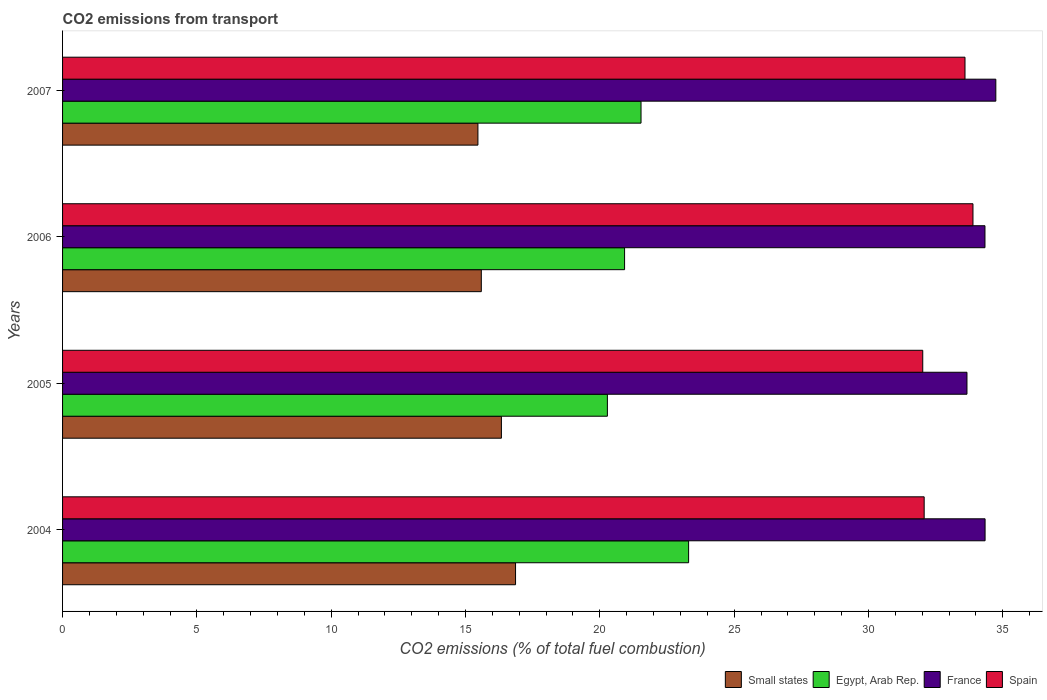How many different coloured bars are there?
Provide a short and direct response. 4. How many groups of bars are there?
Give a very brief answer. 4. How many bars are there on the 2nd tick from the top?
Keep it short and to the point. 4. What is the total CO2 emitted in Small states in 2006?
Your response must be concise. 15.59. Across all years, what is the maximum total CO2 emitted in Egypt, Arab Rep.?
Your answer should be compact. 23.3. Across all years, what is the minimum total CO2 emitted in France?
Make the answer very short. 33.67. In which year was the total CO2 emitted in Spain minimum?
Your answer should be compact. 2005. What is the total total CO2 emitted in Spain in the graph?
Provide a succinct answer. 131.57. What is the difference between the total CO2 emitted in Spain in 2006 and that in 2007?
Provide a succinct answer. 0.3. What is the difference between the total CO2 emitted in France in 2006 and the total CO2 emitted in Egypt, Arab Rep. in 2007?
Your answer should be compact. 12.8. What is the average total CO2 emitted in Egypt, Arab Rep. per year?
Keep it short and to the point. 21.51. In the year 2004, what is the difference between the total CO2 emitted in France and total CO2 emitted in Egypt, Arab Rep.?
Make the answer very short. 11.04. What is the ratio of the total CO2 emitted in Spain in 2005 to that in 2006?
Your response must be concise. 0.94. Is the total CO2 emitted in Spain in 2004 less than that in 2006?
Provide a succinct answer. Yes. Is the difference between the total CO2 emitted in France in 2005 and 2006 greater than the difference between the total CO2 emitted in Egypt, Arab Rep. in 2005 and 2006?
Make the answer very short. No. What is the difference between the highest and the second highest total CO2 emitted in Small states?
Your response must be concise. 0.53. What is the difference between the highest and the lowest total CO2 emitted in Spain?
Keep it short and to the point. 1.87. Is the sum of the total CO2 emitted in France in 2004 and 2005 greater than the maximum total CO2 emitted in Spain across all years?
Your answer should be compact. Yes. Is it the case that in every year, the sum of the total CO2 emitted in France and total CO2 emitted in Small states is greater than the sum of total CO2 emitted in Spain and total CO2 emitted in Egypt, Arab Rep.?
Keep it short and to the point. Yes. What does the 1st bar from the top in 2005 represents?
Make the answer very short. Spain. Is it the case that in every year, the sum of the total CO2 emitted in Small states and total CO2 emitted in Spain is greater than the total CO2 emitted in Egypt, Arab Rep.?
Ensure brevity in your answer.  Yes. How many bars are there?
Give a very brief answer. 16. Are all the bars in the graph horizontal?
Keep it short and to the point. Yes. How many years are there in the graph?
Keep it short and to the point. 4. Does the graph contain any zero values?
Your answer should be compact. No. What is the title of the graph?
Give a very brief answer. CO2 emissions from transport. What is the label or title of the X-axis?
Your response must be concise. CO2 emissions (% of total fuel combustion). What is the label or title of the Y-axis?
Your response must be concise. Years. What is the CO2 emissions (% of total fuel combustion) in Small states in 2004?
Your answer should be compact. 16.86. What is the CO2 emissions (% of total fuel combustion) in Egypt, Arab Rep. in 2004?
Give a very brief answer. 23.3. What is the CO2 emissions (% of total fuel combustion) of France in 2004?
Your response must be concise. 34.34. What is the CO2 emissions (% of total fuel combustion) of Spain in 2004?
Offer a very short reply. 32.07. What is the CO2 emissions (% of total fuel combustion) in Small states in 2005?
Offer a terse response. 16.34. What is the CO2 emissions (% of total fuel combustion) in Egypt, Arab Rep. in 2005?
Your response must be concise. 20.28. What is the CO2 emissions (% of total fuel combustion) in France in 2005?
Your answer should be compact. 33.67. What is the CO2 emissions (% of total fuel combustion) in Spain in 2005?
Make the answer very short. 32.02. What is the CO2 emissions (% of total fuel combustion) of Small states in 2006?
Provide a short and direct response. 15.59. What is the CO2 emissions (% of total fuel combustion) in Egypt, Arab Rep. in 2006?
Offer a terse response. 20.92. What is the CO2 emissions (% of total fuel combustion) of France in 2006?
Keep it short and to the point. 34.34. What is the CO2 emissions (% of total fuel combustion) of Spain in 2006?
Ensure brevity in your answer.  33.89. What is the CO2 emissions (% of total fuel combustion) in Small states in 2007?
Offer a terse response. 15.46. What is the CO2 emissions (% of total fuel combustion) of Egypt, Arab Rep. in 2007?
Your answer should be very brief. 21.53. What is the CO2 emissions (% of total fuel combustion) of France in 2007?
Provide a succinct answer. 34.74. What is the CO2 emissions (% of total fuel combustion) of Spain in 2007?
Offer a terse response. 33.59. Across all years, what is the maximum CO2 emissions (% of total fuel combustion) of Small states?
Your response must be concise. 16.86. Across all years, what is the maximum CO2 emissions (% of total fuel combustion) in Egypt, Arab Rep.?
Your answer should be compact. 23.3. Across all years, what is the maximum CO2 emissions (% of total fuel combustion) of France?
Offer a terse response. 34.74. Across all years, what is the maximum CO2 emissions (% of total fuel combustion) of Spain?
Your response must be concise. 33.89. Across all years, what is the minimum CO2 emissions (% of total fuel combustion) in Small states?
Ensure brevity in your answer.  15.46. Across all years, what is the minimum CO2 emissions (% of total fuel combustion) of Egypt, Arab Rep.?
Give a very brief answer. 20.28. Across all years, what is the minimum CO2 emissions (% of total fuel combustion) of France?
Make the answer very short. 33.67. Across all years, what is the minimum CO2 emissions (% of total fuel combustion) in Spain?
Ensure brevity in your answer.  32.02. What is the total CO2 emissions (% of total fuel combustion) in Small states in the graph?
Your response must be concise. 64.25. What is the total CO2 emissions (% of total fuel combustion) in Egypt, Arab Rep. in the graph?
Offer a terse response. 86.04. What is the total CO2 emissions (% of total fuel combustion) in France in the graph?
Your answer should be very brief. 137.08. What is the total CO2 emissions (% of total fuel combustion) of Spain in the graph?
Offer a very short reply. 131.57. What is the difference between the CO2 emissions (% of total fuel combustion) of Small states in 2004 and that in 2005?
Provide a succinct answer. 0.53. What is the difference between the CO2 emissions (% of total fuel combustion) in Egypt, Arab Rep. in 2004 and that in 2005?
Provide a short and direct response. 3.02. What is the difference between the CO2 emissions (% of total fuel combustion) of France in 2004 and that in 2005?
Provide a succinct answer. 0.67. What is the difference between the CO2 emissions (% of total fuel combustion) of Spain in 2004 and that in 2005?
Provide a succinct answer. 0.05. What is the difference between the CO2 emissions (% of total fuel combustion) of Small states in 2004 and that in 2006?
Offer a terse response. 1.27. What is the difference between the CO2 emissions (% of total fuel combustion) of Egypt, Arab Rep. in 2004 and that in 2006?
Offer a terse response. 2.38. What is the difference between the CO2 emissions (% of total fuel combustion) of France in 2004 and that in 2006?
Provide a short and direct response. 0. What is the difference between the CO2 emissions (% of total fuel combustion) of Spain in 2004 and that in 2006?
Make the answer very short. -1.82. What is the difference between the CO2 emissions (% of total fuel combustion) of Small states in 2004 and that in 2007?
Ensure brevity in your answer.  1.4. What is the difference between the CO2 emissions (% of total fuel combustion) of Egypt, Arab Rep. in 2004 and that in 2007?
Give a very brief answer. 1.77. What is the difference between the CO2 emissions (% of total fuel combustion) in Spain in 2004 and that in 2007?
Give a very brief answer. -1.52. What is the difference between the CO2 emissions (% of total fuel combustion) of Small states in 2005 and that in 2006?
Ensure brevity in your answer.  0.75. What is the difference between the CO2 emissions (% of total fuel combustion) of Egypt, Arab Rep. in 2005 and that in 2006?
Ensure brevity in your answer.  -0.64. What is the difference between the CO2 emissions (% of total fuel combustion) of France in 2005 and that in 2006?
Your answer should be compact. -0.67. What is the difference between the CO2 emissions (% of total fuel combustion) of Spain in 2005 and that in 2006?
Your response must be concise. -1.87. What is the difference between the CO2 emissions (% of total fuel combustion) in Small states in 2005 and that in 2007?
Offer a terse response. 0.87. What is the difference between the CO2 emissions (% of total fuel combustion) of Egypt, Arab Rep. in 2005 and that in 2007?
Provide a succinct answer. -1.25. What is the difference between the CO2 emissions (% of total fuel combustion) in France in 2005 and that in 2007?
Offer a very short reply. -1.07. What is the difference between the CO2 emissions (% of total fuel combustion) of Spain in 2005 and that in 2007?
Your response must be concise. -1.57. What is the difference between the CO2 emissions (% of total fuel combustion) in Small states in 2006 and that in 2007?
Provide a short and direct response. 0.13. What is the difference between the CO2 emissions (% of total fuel combustion) in Egypt, Arab Rep. in 2006 and that in 2007?
Offer a very short reply. -0.61. What is the difference between the CO2 emissions (% of total fuel combustion) in France in 2006 and that in 2007?
Keep it short and to the point. -0.4. What is the difference between the CO2 emissions (% of total fuel combustion) of Spain in 2006 and that in 2007?
Give a very brief answer. 0.3. What is the difference between the CO2 emissions (% of total fuel combustion) in Small states in 2004 and the CO2 emissions (% of total fuel combustion) in Egypt, Arab Rep. in 2005?
Offer a terse response. -3.42. What is the difference between the CO2 emissions (% of total fuel combustion) in Small states in 2004 and the CO2 emissions (% of total fuel combustion) in France in 2005?
Provide a succinct answer. -16.8. What is the difference between the CO2 emissions (% of total fuel combustion) of Small states in 2004 and the CO2 emissions (% of total fuel combustion) of Spain in 2005?
Your answer should be compact. -15.16. What is the difference between the CO2 emissions (% of total fuel combustion) in Egypt, Arab Rep. in 2004 and the CO2 emissions (% of total fuel combustion) in France in 2005?
Make the answer very short. -10.36. What is the difference between the CO2 emissions (% of total fuel combustion) of Egypt, Arab Rep. in 2004 and the CO2 emissions (% of total fuel combustion) of Spain in 2005?
Give a very brief answer. -8.72. What is the difference between the CO2 emissions (% of total fuel combustion) in France in 2004 and the CO2 emissions (% of total fuel combustion) in Spain in 2005?
Provide a succinct answer. 2.32. What is the difference between the CO2 emissions (% of total fuel combustion) in Small states in 2004 and the CO2 emissions (% of total fuel combustion) in Egypt, Arab Rep. in 2006?
Provide a short and direct response. -4.06. What is the difference between the CO2 emissions (% of total fuel combustion) in Small states in 2004 and the CO2 emissions (% of total fuel combustion) in France in 2006?
Offer a terse response. -17.47. What is the difference between the CO2 emissions (% of total fuel combustion) of Small states in 2004 and the CO2 emissions (% of total fuel combustion) of Spain in 2006?
Give a very brief answer. -17.03. What is the difference between the CO2 emissions (% of total fuel combustion) in Egypt, Arab Rep. in 2004 and the CO2 emissions (% of total fuel combustion) in France in 2006?
Ensure brevity in your answer.  -11.03. What is the difference between the CO2 emissions (% of total fuel combustion) in Egypt, Arab Rep. in 2004 and the CO2 emissions (% of total fuel combustion) in Spain in 2006?
Ensure brevity in your answer.  -10.58. What is the difference between the CO2 emissions (% of total fuel combustion) in France in 2004 and the CO2 emissions (% of total fuel combustion) in Spain in 2006?
Provide a short and direct response. 0.45. What is the difference between the CO2 emissions (% of total fuel combustion) of Small states in 2004 and the CO2 emissions (% of total fuel combustion) of Egypt, Arab Rep. in 2007?
Offer a terse response. -4.67. What is the difference between the CO2 emissions (% of total fuel combustion) in Small states in 2004 and the CO2 emissions (% of total fuel combustion) in France in 2007?
Provide a succinct answer. -17.88. What is the difference between the CO2 emissions (% of total fuel combustion) of Small states in 2004 and the CO2 emissions (% of total fuel combustion) of Spain in 2007?
Make the answer very short. -16.73. What is the difference between the CO2 emissions (% of total fuel combustion) of Egypt, Arab Rep. in 2004 and the CO2 emissions (% of total fuel combustion) of France in 2007?
Offer a terse response. -11.44. What is the difference between the CO2 emissions (% of total fuel combustion) in Egypt, Arab Rep. in 2004 and the CO2 emissions (% of total fuel combustion) in Spain in 2007?
Keep it short and to the point. -10.29. What is the difference between the CO2 emissions (% of total fuel combustion) of France in 2004 and the CO2 emissions (% of total fuel combustion) of Spain in 2007?
Offer a terse response. 0.75. What is the difference between the CO2 emissions (% of total fuel combustion) of Small states in 2005 and the CO2 emissions (% of total fuel combustion) of Egypt, Arab Rep. in 2006?
Give a very brief answer. -4.58. What is the difference between the CO2 emissions (% of total fuel combustion) of Small states in 2005 and the CO2 emissions (% of total fuel combustion) of France in 2006?
Your answer should be compact. -18. What is the difference between the CO2 emissions (% of total fuel combustion) of Small states in 2005 and the CO2 emissions (% of total fuel combustion) of Spain in 2006?
Your answer should be compact. -17.55. What is the difference between the CO2 emissions (% of total fuel combustion) of Egypt, Arab Rep. in 2005 and the CO2 emissions (% of total fuel combustion) of France in 2006?
Your response must be concise. -14.05. What is the difference between the CO2 emissions (% of total fuel combustion) of Egypt, Arab Rep. in 2005 and the CO2 emissions (% of total fuel combustion) of Spain in 2006?
Your answer should be very brief. -13.61. What is the difference between the CO2 emissions (% of total fuel combustion) of France in 2005 and the CO2 emissions (% of total fuel combustion) of Spain in 2006?
Provide a short and direct response. -0.22. What is the difference between the CO2 emissions (% of total fuel combustion) of Small states in 2005 and the CO2 emissions (% of total fuel combustion) of Egypt, Arab Rep. in 2007?
Keep it short and to the point. -5.2. What is the difference between the CO2 emissions (% of total fuel combustion) of Small states in 2005 and the CO2 emissions (% of total fuel combustion) of France in 2007?
Offer a very short reply. -18.4. What is the difference between the CO2 emissions (% of total fuel combustion) of Small states in 2005 and the CO2 emissions (% of total fuel combustion) of Spain in 2007?
Provide a short and direct response. -17.26. What is the difference between the CO2 emissions (% of total fuel combustion) in Egypt, Arab Rep. in 2005 and the CO2 emissions (% of total fuel combustion) in France in 2007?
Offer a terse response. -14.46. What is the difference between the CO2 emissions (% of total fuel combustion) in Egypt, Arab Rep. in 2005 and the CO2 emissions (% of total fuel combustion) in Spain in 2007?
Your answer should be compact. -13.31. What is the difference between the CO2 emissions (% of total fuel combustion) in France in 2005 and the CO2 emissions (% of total fuel combustion) in Spain in 2007?
Provide a succinct answer. 0.07. What is the difference between the CO2 emissions (% of total fuel combustion) of Small states in 2006 and the CO2 emissions (% of total fuel combustion) of Egypt, Arab Rep. in 2007?
Your answer should be compact. -5.95. What is the difference between the CO2 emissions (% of total fuel combustion) in Small states in 2006 and the CO2 emissions (% of total fuel combustion) in France in 2007?
Ensure brevity in your answer.  -19.15. What is the difference between the CO2 emissions (% of total fuel combustion) in Small states in 2006 and the CO2 emissions (% of total fuel combustion) in Spain in 2007?
Your answer should be very brief. -18. What is the difference between the CO2 emissions (% of total fuel combustion) in Egypt, Arab Rep. in 2006 and the CO2 emissions (% of total fuel combustion) in France in 2007?
Your response must be concise. -13.82. What is the difference between the CO2 emissions (% of total fuel combustion) of Egypt, Arab Rep. in 2006 and the CO2 emissions (% of total fuel combustion) of Spain in 2007?
Make the answer very short. -12.67. What is the difference between the CO2 emissions (% of total fuel combustion) in France in 2006 and the CO2 emissions (% of total fuel combustion) in Spain in 2007?
Your response must be concise. 0.74. What is the average CO2 emissions (% of total fuel combustion) of Small states per year?
Your response must be concise. 16.06. What is the average CO2 emissions (% of total fuel combustion) in Egypt, Arab Rep. per year?
Your answer should be very brief. 21.51. What is the average CO2 emissions (% of total fuel combustion) in France per year?
Provide a succinct answer. 34.27. What is the average CO2 emissions (% of total fuel combustion) in Spain per year?
Your answer should be compact. 32.89. In the year 2004, what is the difference between the CO2 emissions (% of total fuel combustion) in Small states and CO2 emissions (% of total fuel combustion) in Egypt, Arab Rep.?
Your response must be concise. -6.44. In the year 2004, what is the difference between the CO2 emissions (% of total fuel combustion) of Small states and CO2 emissions (% of total fuel combustion) of France?
Make the answer very short. -17.48. In the year 2004, what is the difference between the CO2 emissions (% of total fuel combustion) of Small states and CO2 emissions (% of total fuel combustion) of Spain?
Offer a terse response. -15.21. In the year 2004, what is the difference between the CO2 emissions (% of total fuel combustion) in Egypt, Arab Rep. and CO2 emissions (% of total fuel combustion) in France?
Your response must be concise. -11.04. In the year 2004, what is the difference between the CO2 emissions (% of total fuel combustion) of Egypt, Arab Rep. and CO2 emissions (% of total fuel combustion) of Spain?
Your answer should be compact. -8.77. In the year 2004, what is the difference between the CO2 emissions (% of total fuel combustion) in France and CO2 emissions (% of total fuel combustion) in Spain?
Make the answer very short. 2.27. In the year 2005, what is the difference between the CO2 emissions (% of total fuel combustion) of Small states and CO2 emissions (% of total fuel combustion) of Egypt, Arab Rep.?
Your answer should be compact. -3.95. In the year 2005, what is the difference between the CO2 emissions (% of total fuel combustion) in Small states and CO2 emissions (% of total fuel combustion) in France?
Provide a short and direct response. -17.33. In the year 2005, what is the difference between the CO2 emissions (% of total fuel combustion) in Small states and CO2 emissions (% of total fuel combustion) in Spain?
Offer a very short reply. -15.68. In the year 2005, what is the difference between the CO2 emissions (% of total fuel combustion) in Egypt, Arab Rep. and CO2 emissions (% of total fuel combustion) in France?
Make the answer very short. -13.38. In the year 2005, what is the difference between the CO2 emissions (% of total fuel combustion) of Egypt, Arab Rep. and CO2 emissions (% of total fuel combustion) of Spain?
Ensure brevity in your answer.  -11.74. In the year 2005, what is the difference between the CO2 emissions (% of total fuel combustion) in France and CO2 emissions (% of total fuel combustion) in Spain?
Offer a very short reply. 1.65. In the year 2006, what is the difference between the CO2 emissions (% of total fuel combustion) of Small states and CO2 emissions (% of total fuel combustion) of Egypt, Arab Rep.?
Make the answer very short. -5.33. In the year 2006, what is the difference between the CO2 emissions (% of total fuel combustion) in Small states and CO2 emissions (% of total fuel combustion) in France?
Offer a terse response. -18.75. In the year 2006, what is the difference between the CO2 emissions (% of total fuel combustion) in Small states and CO2 emissions (% of total fuel combustion) in Spain?
Provide a short and direct response. -18.3. In the year 2006, what is the difference between the CO2 emissions (% of total fuel combustion) in Egypt, Arab Rep. and CO2 emissions (% of total fuel combustion) in France?
Ensure brevity in your answer.  -13.42. In the year 2006, what is the difference between the CO2 emissions (% of total fuel combustion) of Egypt, Arab Rep. and CO2 emissions (% of total fuel combustion) of Spain?
Offer a terse response. -12.97. In the year 2006, what is the difference between the CO2 emissions (% of total fuel combustion) in France and CO2 emissions (% of total fuel combustion) in Spain?
Offer a terse response. 0.45. In the year 2007, what is the difference between the CO2 emissions (% of total fuel combustion) in Small states and CO2 emissions (% of total fuel combustion) in Egypt, Arab Rep.?
Give a very brief answer. -6.07. In the year 2007, what is the difference between the CO2 emissions (% of total fuel combustion) in Small states and CO2 emissions (% of total fuel combustion) in France?
Ensure brevity in your answer.  -19.28. In the year 2007, what is the difference between the CO2 emissions (% of total fuel combustion) of Small states and CO2 emissions (% of total fuel combustion) of Spain?
Offer a very short reply. -18.13. In the year 2007, what is the difference between the CO2 emissions (% of total fuel combustion) in Egypt, Arab Rep. and CO2 emissions (% of total fuel combustion) in France?
Make the answer very short. -13.21. In the year 2007, what is the difference between the CO2 emissions (% of total fuel combustion) in Egypt, Arab Rep. and CO2 emissions (% of total fuel combustion) in Spain?
Make the answer very short. -12.06. In the year 2007, what is the difference between the CO2 emissions (% of total fuel combustion) of France and CO2 emissions (% of total fuel combustion) of Spain?
Your response must be concise. 1.15. What is the ratio of the CO2 emissions (% of total fuel combustion) of Small states in 2004 to that in 2005?
Provide a succinct answer. 1.03. What is the ratio of the CO2 emissions (% of total fuel combustion) in Egypt, Arab Rep. in 2004 to that in 2005?
Keep it short and to the point. 1.15. What is the ratio of the CO2 emissions (% of total fuel combustion) in France in 2004 to that in 2005?
Offer a very short reply. 1.02. What is the ratio of the CO2 emissions (% of total fuel combustion) in Spain in 2004 to that in 2005?
Provide a succinct answer. 1. What is the ratio of the CO2 emissions (% of total fuel combustion) of Small states in 2004 to that in 2006?
Provide a succinct answer. 1.08. What is the ratio of the CO2 emissions (% of total fuel combustion) in Egypt, Arab Rep. in 2004 to that in 2006?
Keep it short and to the point. 1.11. What is the ratio of the CO2 emissions (% of total fuel combustion) in Spain in 2004 to that in 2006?
Your answer should be very brief. 0.95. What is the ratio of the CO2 emissions (% of total fuel combustion) in Small states in 2004 to that in 2007?
Offer a terse response. 1.09. What is the ratio of the CO2 emissions (% of total fuel combustion) of Egypt, Arab Rep. in 2004 to that in 2007?
Your answer should be compact. 1.08. What is the ratio of the CO2 emissions (% of total fuel combustion) of France in 2004 to that in 2007?
Provide a succinct answer. 0.99. What is the ratio of the CO2 emissions (% of total fuel combustion) in Spain in 2004 to that in 2007?
Your response must be concise. 0.95. What is the ratio of the CO2 emissions (% of total fuel combustion) of Small states in 2005 to that in 2006?
Your answer should be very brief. 1.05. What is the ratio of the CO2 emissions (% of total fuel combustion) of Egypt, Arab Rep. in 2005 to that in 2006?
Make the answer very short. 0.97. What is the ratio of the CO2 emissions (% of total fuel combustion) in France in 2005 to that in 2006?
Keep it short and to the point. 0.98. What is the ratio of the CO2 emissions (% of total fuel combustion) in Spain in 2005 to that in 2006?
Make the answer very short. 0.94. What is the ratio of the CO2 emissions (% of total fuel combustion) in Small states in 2005 to that in 2007?
Offer a very short reply. 1.06. What is the ratio of the CO2 emissions (% of total fuel combustion) in Egypt, Arab Rep. in 2005 to that in 2007?
Give a very brief answer. 0.94. What is the ratio of the CO2 emissions (% of total fuel combustion) in France in 2005 to that in 2007?
Offer a terse response. 0.97. What is the ratio of the CO2 emissions (% of total fuel combustion) of Spain in 2005 to that in 2007?
Provide a short and direct response. 0.95. What is the ratio of the CO2 emissions (% of total fuel combustion) of Egypt, Arab Rep. in 2006 to that in 2007?
Provide a succinct answer. 0.97. What is the ratio of the CO2 emissions (% of total fuel combustion) of France in 2006 to that in 2007?
Keep it short and to the point. 0.99. What is the ratio of the CO2 emissions (% of total fuel combustion) of Spain in 2006 to that in 2007?
Give a very brief answer. 1.01. What is the difference between the highest and the second highest CO2 emissions (% of total fuel combustion) of Small states?
Offer a terse response. 0.53. What is the difference between the highest and the second highest CO2 emissions (% of total fuel combustion) of Egypt, Arab Rep.?
Your response must be concise. 1.77. What is the difference between the highest and the second highest CO2 emissions (% of total fuel combustion) of France?
Give a very brief answer. 0.4. What is the difference between the highest and the second highest CO2 emissions (% of total fuel combustion) of Spain?
Give a very brief answer. 0.3. What is the difference between the highest and the lowest CO2 emissions (% of total fuel combustion) of Small states?
Offer a very short reply. 1.4. What is the difference between the highest and the lowest CO2 emissions (% of total fuel combustion) in Egypt, Arab Rep.?
Offer a very short reply. 3.02. What is the difference between the highest and the lowest CO2 emissions (% of total fuel combustion) in France?
Offer a very short reply. 1.07. What is the difference between the highest and the lowest CO2 emissions (% of total fuel combustion) of Spain?
Offer a very short reply. 1.87. 